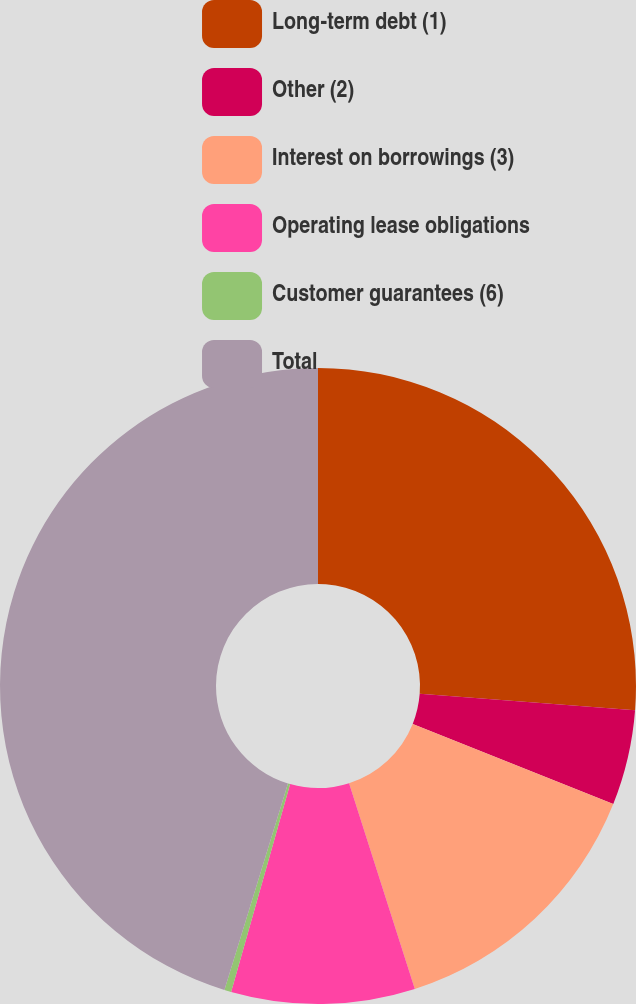Convert chart to OTSL. <chart><loc_0><loc_0><loc_500><loc_500><pie_chart><fcel>Long-term debt (1)<fcel>Other (2)<fcel>Interest on borrowings (3)<fcel>Operating lease obligations<fcel>Customer guarantees (6)<fcel>Total<nl><fcel>26.22%<fcel>4.84%<fcel>14.02%<fcel>9.33%<fcel>0.35%<fcel>45.25%<nl></chart> 